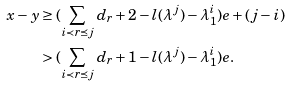<formula> <loc_0><loc_0><loc_500><loc_500>x - y & \geq ( \sum _ { i \prec r \preceq j } d _ { r } + 2 - l ( \lambda ^ { j } ) - \lambda ^ { i } _ { 1 } ) e + ( j - i ) \\ & > ( \sum _ { i \prec r \preceq j } d _ { r } + 1 - l ( \lambda ^ { j } ) - \lambda ^ { i } _ { 1 } ) e .</formula> 